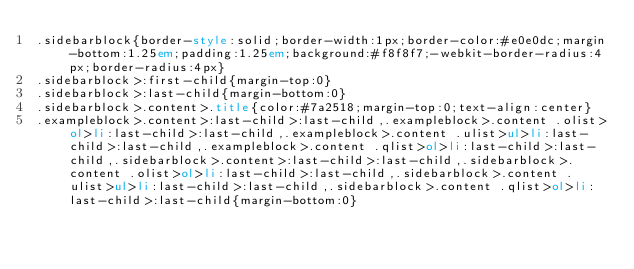Convert code to text. <code><loc_0><loc_0><loc_500><loc_500><_HTML_>.sidebarblock{border-style:solid;border-width:1px;border-color:#e0e0dc;margin-bottom:1.25em;padding:1.25em;background:#f8f8f7;-webkit-border-radius:4px;border-radius:4px}
.sidebarblock>:first-child{margin-top:0}
.sidebarblock>:last-child{margin-bottom:0}
.sidebarblock>.content>.title{color:#7a2518;margin-top:0;text-align:center}
.exampleblock>.content>:last-child>:last-child,.exampleblock>.content .olist>ol>li:last-child>:last-child,.exampleblock>.content .ulist>ul>li:last-child>:last-child,.exampleblock>.content .qlist>ol>li:last-child>:last-child,.sidebarblock>.content>:last-child>:last-child,.sidebarblock>.content .olist>ol>li:last-child>:last-child,.sidebarblock>.content .ulist>ul>li:last-child>:last-child,.sidebarblock>.content .qlist>ol>li:last-child>:last-child{margin-bottom:0}</code> 